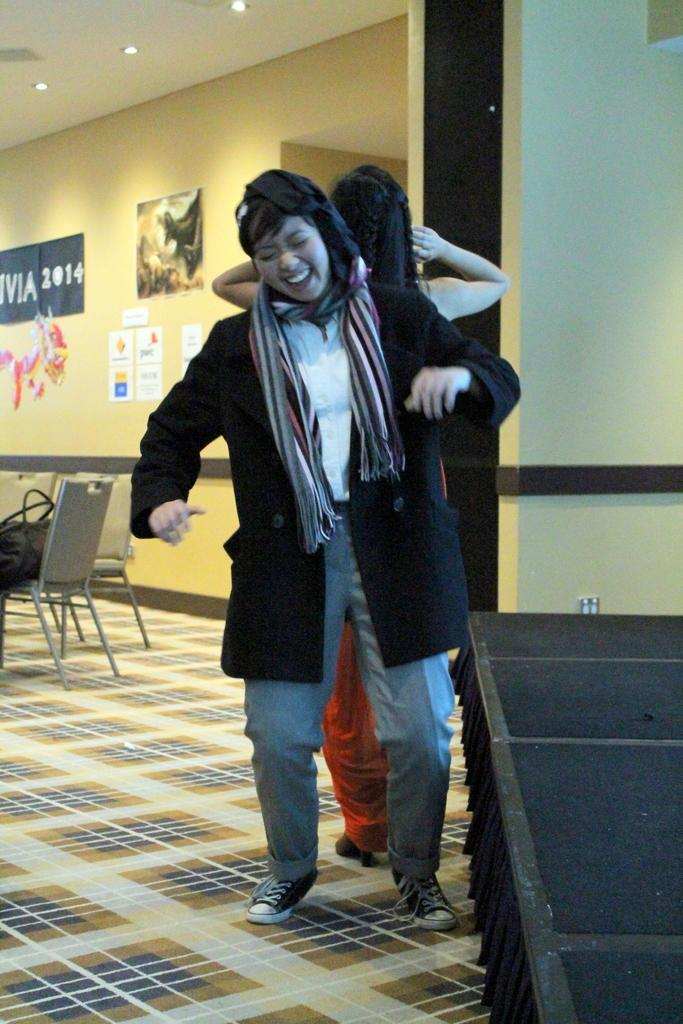How many people are in the image? There are two persons standing in the image. What is the facial expression of one of the persons? One of the persons is smiling. What type of furniture is present in the image? There are chairs in the image. What can be seen in the background of the image? There are posts, lights, and a wall in the background of the image. What type of destruction is being caused by the grandfather in the image? There is no grandfather or destruction present in the image. Is there a spy visible in the image? There is no spy present in the image. 